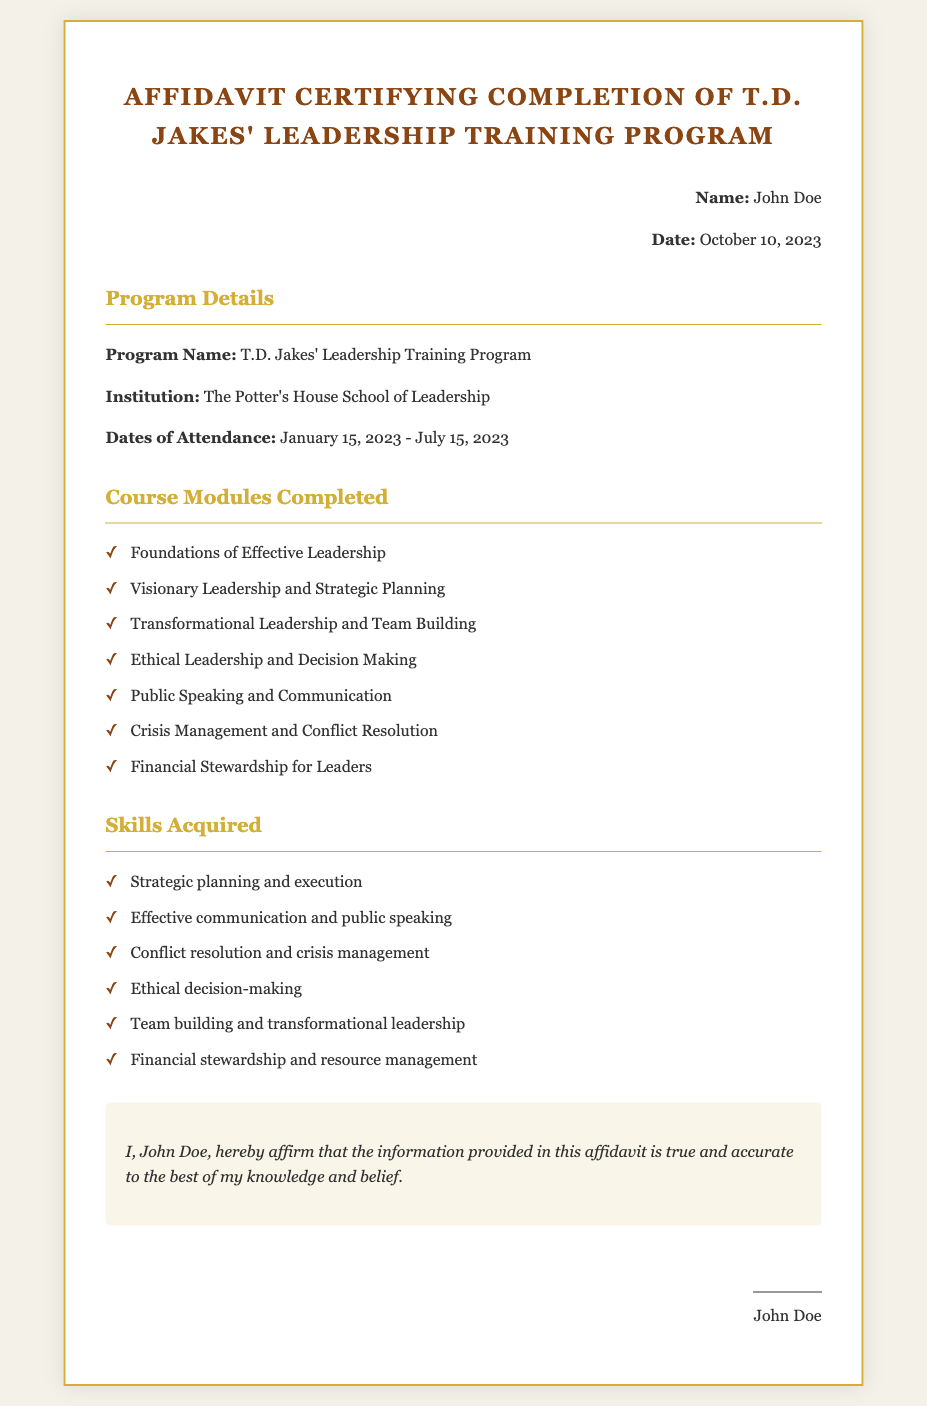What is the name of the program? The name of the program is listed in the document under "Program Name."
Answer: T.D. Jakes' Leadership Training Program Who is the institution providing the training? The institution is mentioned in the "Institution" section.
Answer: The Potter's House School of Leadership What are the dates of attendance? The dates of attendance are specified in the "Dates of Attendance" section.
Answer: January 15, 2023 - July 15, 2023 How many course modules were completed? The number of course modules is derived from counting the items in the "Course Modules Completed" list.
Answer: 7 Name one skill acquired during the training. This information can be found in the "Skills Acquired" section.
Answer: Strategic planning and execution What is the purpose of this affidavit? The purpose is stated in the certification section indicating the affirmation of the information.
Answer: To affirm the completion of the program Who signed the affidavit? The name of the individual who signed the affidavit is provided in the signature section.
Answer: John Doe On what date was the affidavit signed? The signing date is noted under "Date" in the personal details section.
Answer: October 10, 2023 